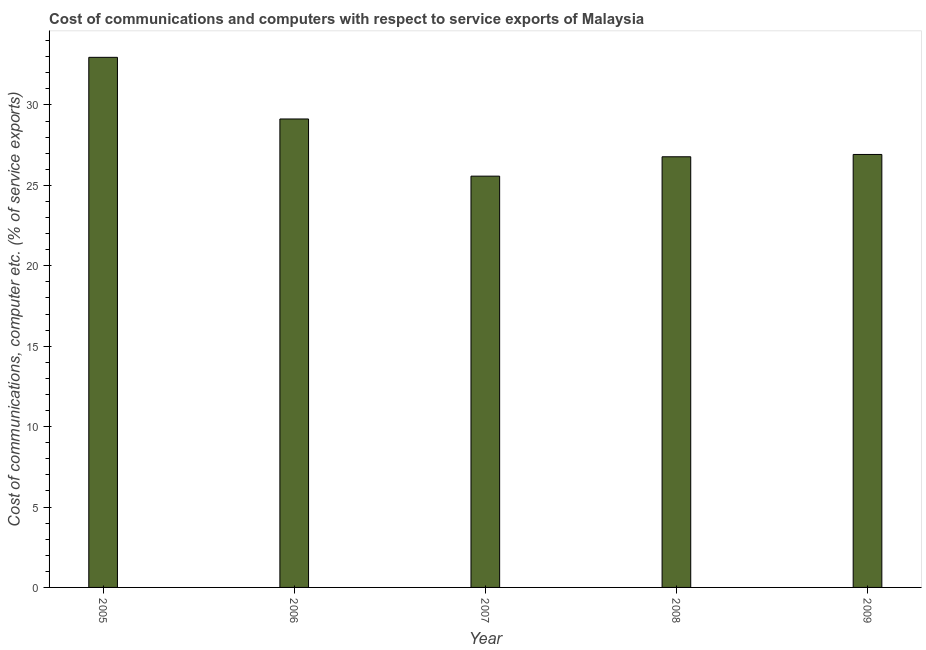Does the graph contain any zero values?
Make the answer very short. No. Does the graph contain grids?
Give a very brief answer. No. What is the title of the graph?
Ensure brevity in your answer.  Cost of communications and computers with respect to service exports of Malaysia. What is the label or title of the Y-axis?
Keep it short and to the point. Cost of communications, computer etc. (% of service exports). What is the cost of communications and computer in 2008?
Provide a short and direct response. 26.78. Across all years, what is the maximum cost of communications and computer?
Your answer should be compact. 32.96. Across all years, what is the minimum cost of communications and computer?
Your response must be concise. 25.57. What is the sum of the cost of communications and computer?
Offer a terse response. 141.37. What is the difference between the cost of communications and computer in 2005 and 2008?
Provide a succinct answer. 6.18. What is the average cost of communications and computer per year?
Your answer should be very brief. 28.27. What is the median cost of communications and computer?
Your response must be concise. 26.92. What is the ratio of the cost of communications and computer in 2005 to that in 2007?
Keep it short and to the point. 1.29. Is the difference between the cost of communications and computer in 2006 and 2007 greater than the difference between any two years?
Offer a very short reply. No. What is the difference between the highest and the second highest cost of communications and computer?
Ensure brevity in your answer.  3.83. What is the difference between the highest and the lowest cost of communications and computer?
Provide a short and direct response. 7.39. In how many years, is the cost of communications and computer greater than the average cost of communications and computer taken over all years?
Make the answer very short. 2. Are the values on the major ticks of Y-axis written in scientific E-notation?
Your answer should be compact. No. What is the Cost of communications, computer etc. (% of service exports) of 2005?
Provide a succinct answer. 32.96. What is the Cost of communications, computer etc. (% of service exports) in 2006?
Give a very brief answer. 29.13. What is the Cost of communications, computer etc. (% of service exports) in 2007?
Offer a very short reply. 25.57. What is the Cost of communications, computer etc. (% of service exports) in 2008?
Offer a terse response. 26.78. What is the Cost of communications, computer etc. (% of service exports) in 2009?
Your answer should be very brief. 26.92. What is the difference between the Cost of communications, computer etc. (% of service exports) in 2005 and 2006?
Your response must be concise. 3.83. What is the difference between the Cost of communications, computer etc. (% of service exports) in 2005 and 2007?
Provide a short and direct response. 7.39. What is the difference between the Cost of communications, computer etc. (% of service exports) in 2005 and 2008?
Your answer should be very brief. 6.18. What is the difference between the Cost of communications, computer etc. (% of service exports) in 2005 and 2009?
Your answer should be compact. 6.04. What is the difference between the Cost of communications, computer etc. (% of service exports) in 2006 and 2007?
Your answer should be very brief. 3.56. What is the difference between the Cost of communications, computer etc. (% of service exports) in 2006 and 2008?
Ensure brevity in your answer.  2.35. What is the difference between the Cost of communications, computer etc. (% of service exports) in 2006 and 2009?
Offer a terse response. 2.21. What is the difference between the Cost of communications, computer etc. (% of service exports) in 2007 and 2008?
Your answer should be very brief. -1.2. What is the difference between the Cost of communications, computer etc. (% of service exports) in 2007 and 2009?
Keep it short and to the point. -1.35. What is the difference between the Cost of communications, computer etc. (% of service exports) in 2008 and 2009?
Make the answer very short. -0.14. What is the ratio of the Cost of communications, computer etc. (% of service exports) in 2005 to that in 2006?
Offer a terse response. 1.13. What is the ratio of the Cost of communications, computer etc. (% of service exports) in 2005 to that in 2007?
Your answer should be very brief. 1.29. What is the ratio of the Cost of communications, computer etc. (% of service exports) in 2005 to that in 2008?
Your response must be concise. 1.23. What is the ratio of the Cost of communications, computer etc. (% of service exports) in 2005 to that in 2009?
Make the answer very short. 1.22. What is the ratio of the Cost of communications, computer etc. (% of service exports) in 2006 to that in 2007?
Your answer should be compact. 1.14. What is the ratio of the Cost of communications, computer etc. (% of service exports) in 2006 to that in 2008?
Give a very brief answer. 1.09. What is the ratio of the Cost of communications, computer etc. (% of service exports) in 2006 to that in 2009?
Provide a short and direct response. 1.08. What is the ratio of the Cost of communications, computer etc. (% of service exports) in 2007 to that in 2008?
Your answer should be compact. 0.95. What is the ratio of the Cost of communications, computer etc. (% of service exports) in 2008 to that in 2009?
Your response must be concise. 0.99. 